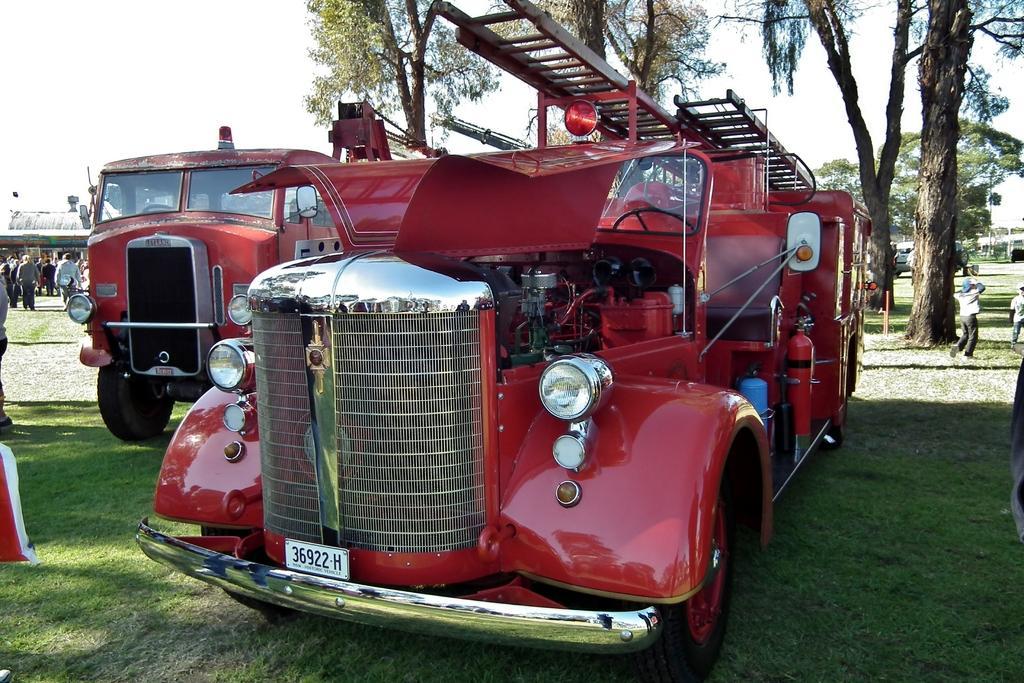Please provide a concise description of this image. In this picture we can see group of people, and few vehicles on the grass, in the background we can see few trees and buildings, and the vehicles are in the red color. 